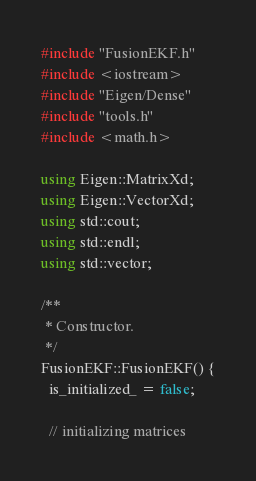<code> <loc_0><loc_0><loc_500><loc_500><_C++_>#include "FusionEKF.h"
#include <iostream>
#include "Eigen/Dense"
#include "tools.h"
#include <math.h>

using Eigen::MatrixXd;
using Eigen::VectorXd;
using std::cout;
using std::endl;
using std::vector;

/**
 * Constructor.
 */
FusionEKF::FusionEKF() {
  is_initialized_ = false;

  // initializing matrices</code> 